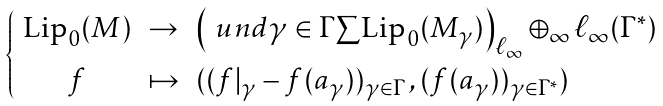Convert formula to latex. <formula><loc_0><loc_0><loc_500><loc_500>\begin{cases} \begin{array} { c c l } \text {Lip} _ { 0 } ( M ) & \to & \left ( \ u n d { \gamma \in \Gamma } { \sum } \text {Lip} _ { 0 } ( M _ { \gamma } ) \right ) _ { \ell _ { \infty } } \oplus _ { \infty } \ell _ { \infty } ( \Gamma ^ { * } ) \\ f & \mapsto & ( ( f | _ { \gamma } - f ( a _ { \gamma } ) ) _ { \gamma \in \Gamma } \, , ( f ( a _ { \gamma } ) ) _ { \gamma \in \Gamma ^ { * } } ) \end{array} \end{cases}</formula> 